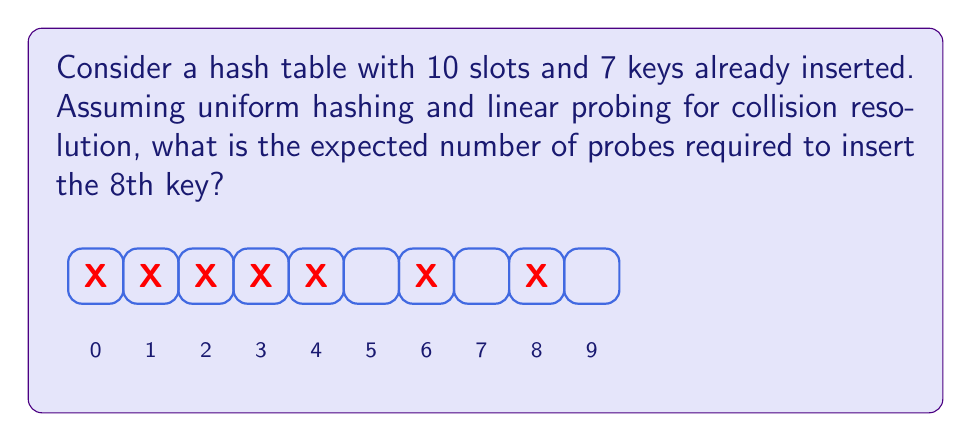What is the answer to this math problem? Let's approach this step-by-step:

1) First, we need to calculate the load factor $\alpha$. The load factor is the ratio of occupied slots to total slots:

   $\alpha = \frac{\text{number of keys}}{\text{total slots}} = \frac{7}{10} = 0.7$

2) For linear probing, the expected number of probes for an unsuccessful search (which is equivalent to inserting a new key) is given by the formula:

   $E[probes] = \frac{1}{2}(1 + \frac{1}{(1-\alpha)^2})$

3) Let's substitute our $\alpha$ value:

   $E[probes] = \frac{1}{2}(1 + \frac{1}{(1-0.7)^2})$

4) Simplify:
   
   $E[probes] = \frac{1}{2}(1 + \frac{1}{0.3^2})$
   
   $E[probes] = \frac{1}{2}(1 + \frac{1}{0.09})$
   
   $E[probes] = \frac{1}{2}(1 + 11.11)$
   
   $E[probes] = \frac{1}{2}(12.11)$
   
   $E[probes] = 6.055$

5) Rounding to two decimal places:

   $E[probes] \approx 6.06$

Thus, the expected number of probes to insert the 8th key is approximately 6.06.
Answer: 6.06 